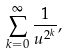Convert formula to latex. <formula><loc_0><loc_0><loc_500><loc_500>\sum _ { k = 0 } ^ { \infty } \frac { 1 } { u ^ { 2 ^ { k } } } ,</formula> 